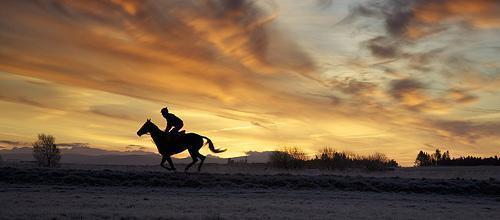How many legs does the animal in the picture have?
Give a very brief answer. 4. How many tails are in the picture?
Give a very brief answer. 1. 